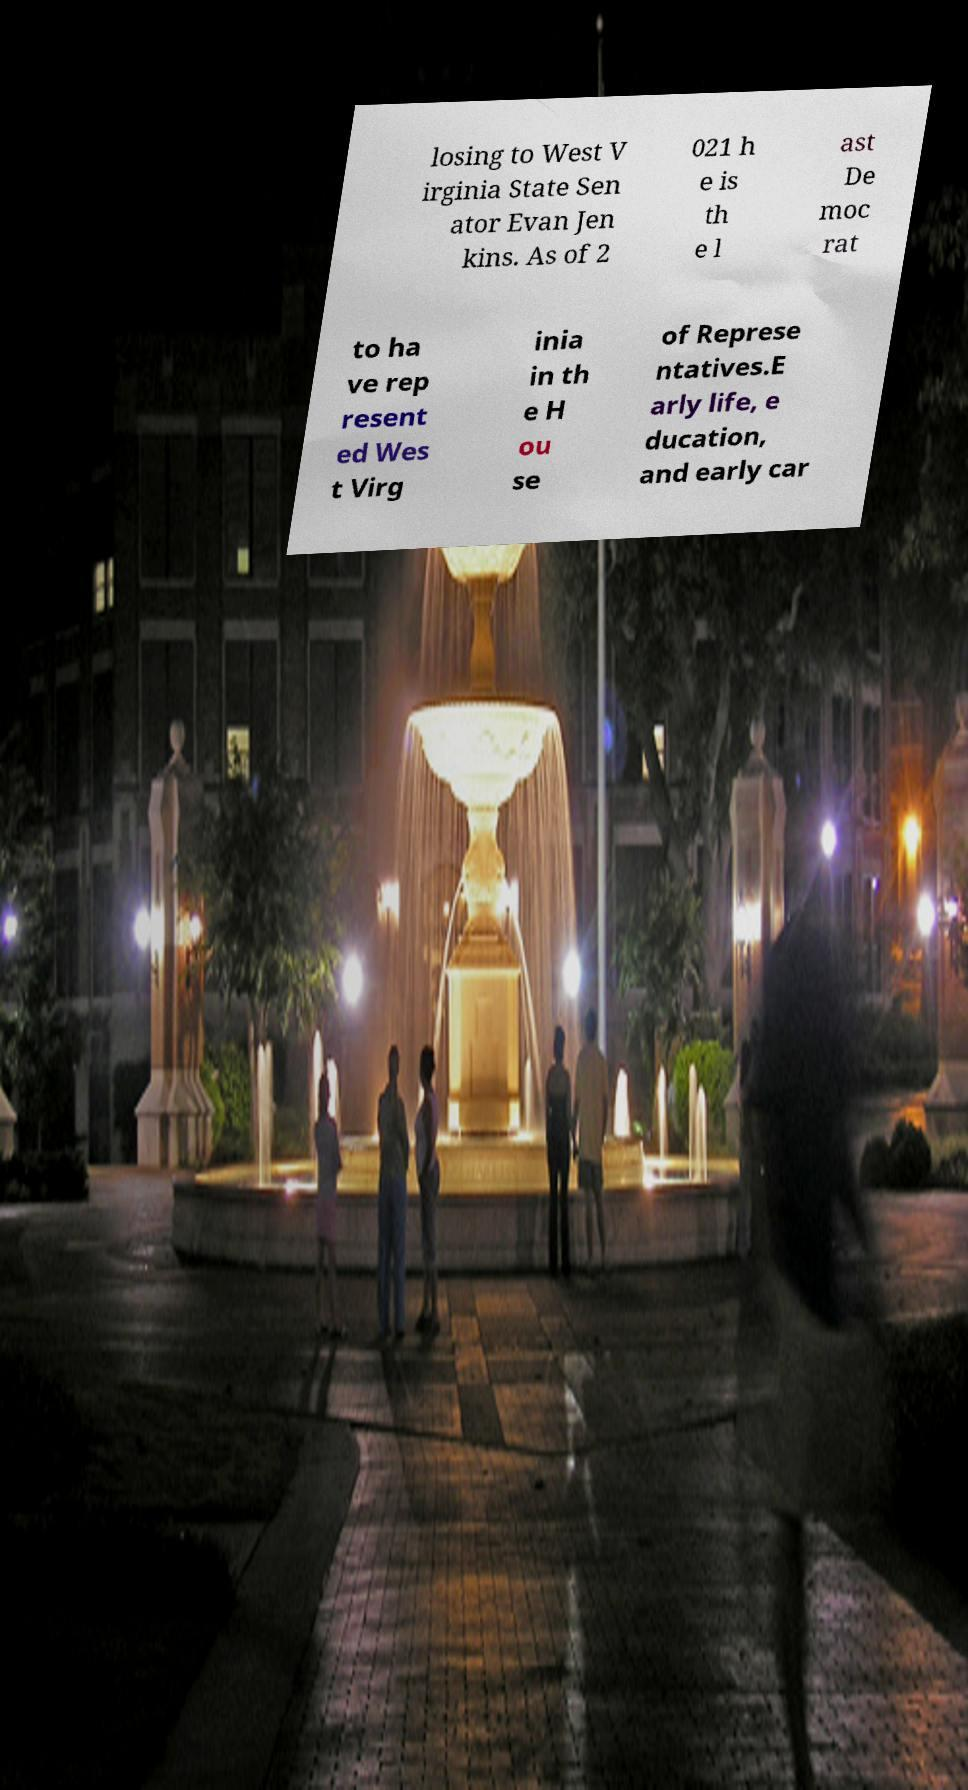Please identify and transcribe the text found in this image. losing to West V irginia State Sen ator Evan Jen kins. As of 2 021 h e is th e l ast De moc rat to ha ve rep resent ed Wes t Virg inia in th e H ou se of Represe ntatives.E arly life, e ducation, and early car 